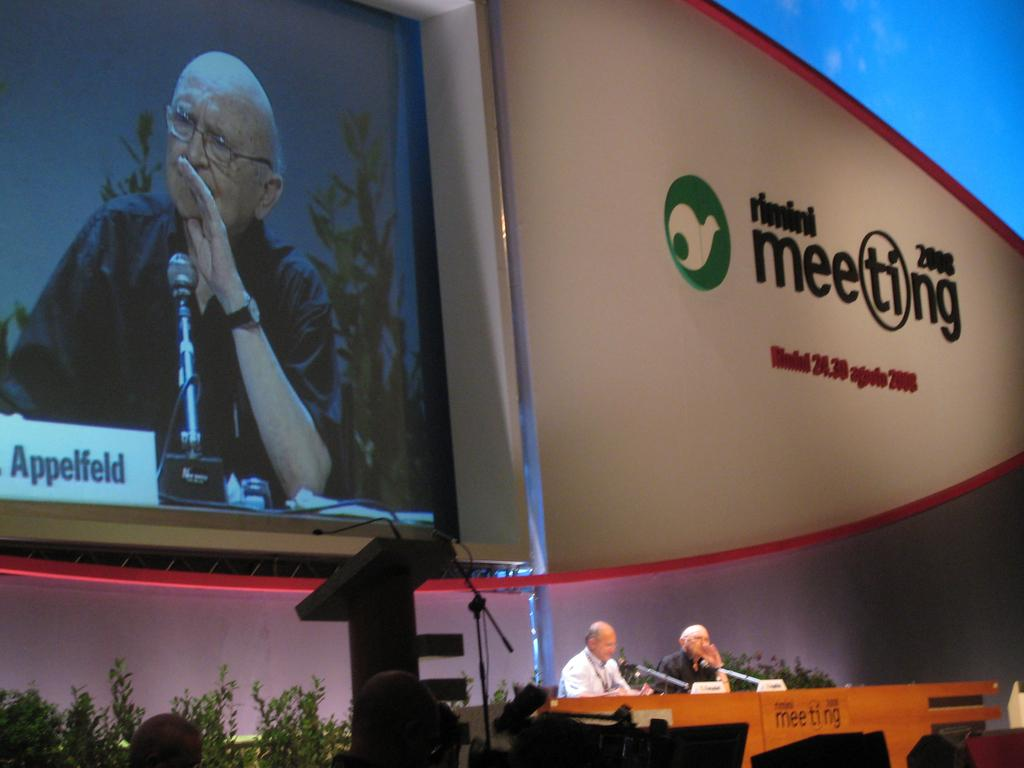<image>
Create a compact narrative representing the image presented. A large screen above men sitting in front of microphones has the year 2008. 